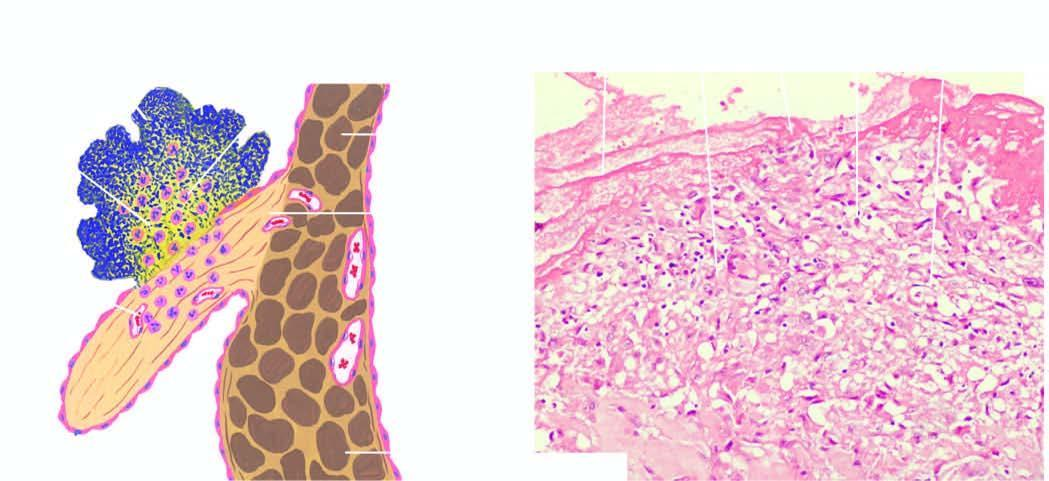does section of the mitral valve show fibrin cap on luminal surface, layer of bacteria, and deeper zone of inflammatory cells, with prominence of neutrophils?
Answer the question using a single word or phrase. Yes 